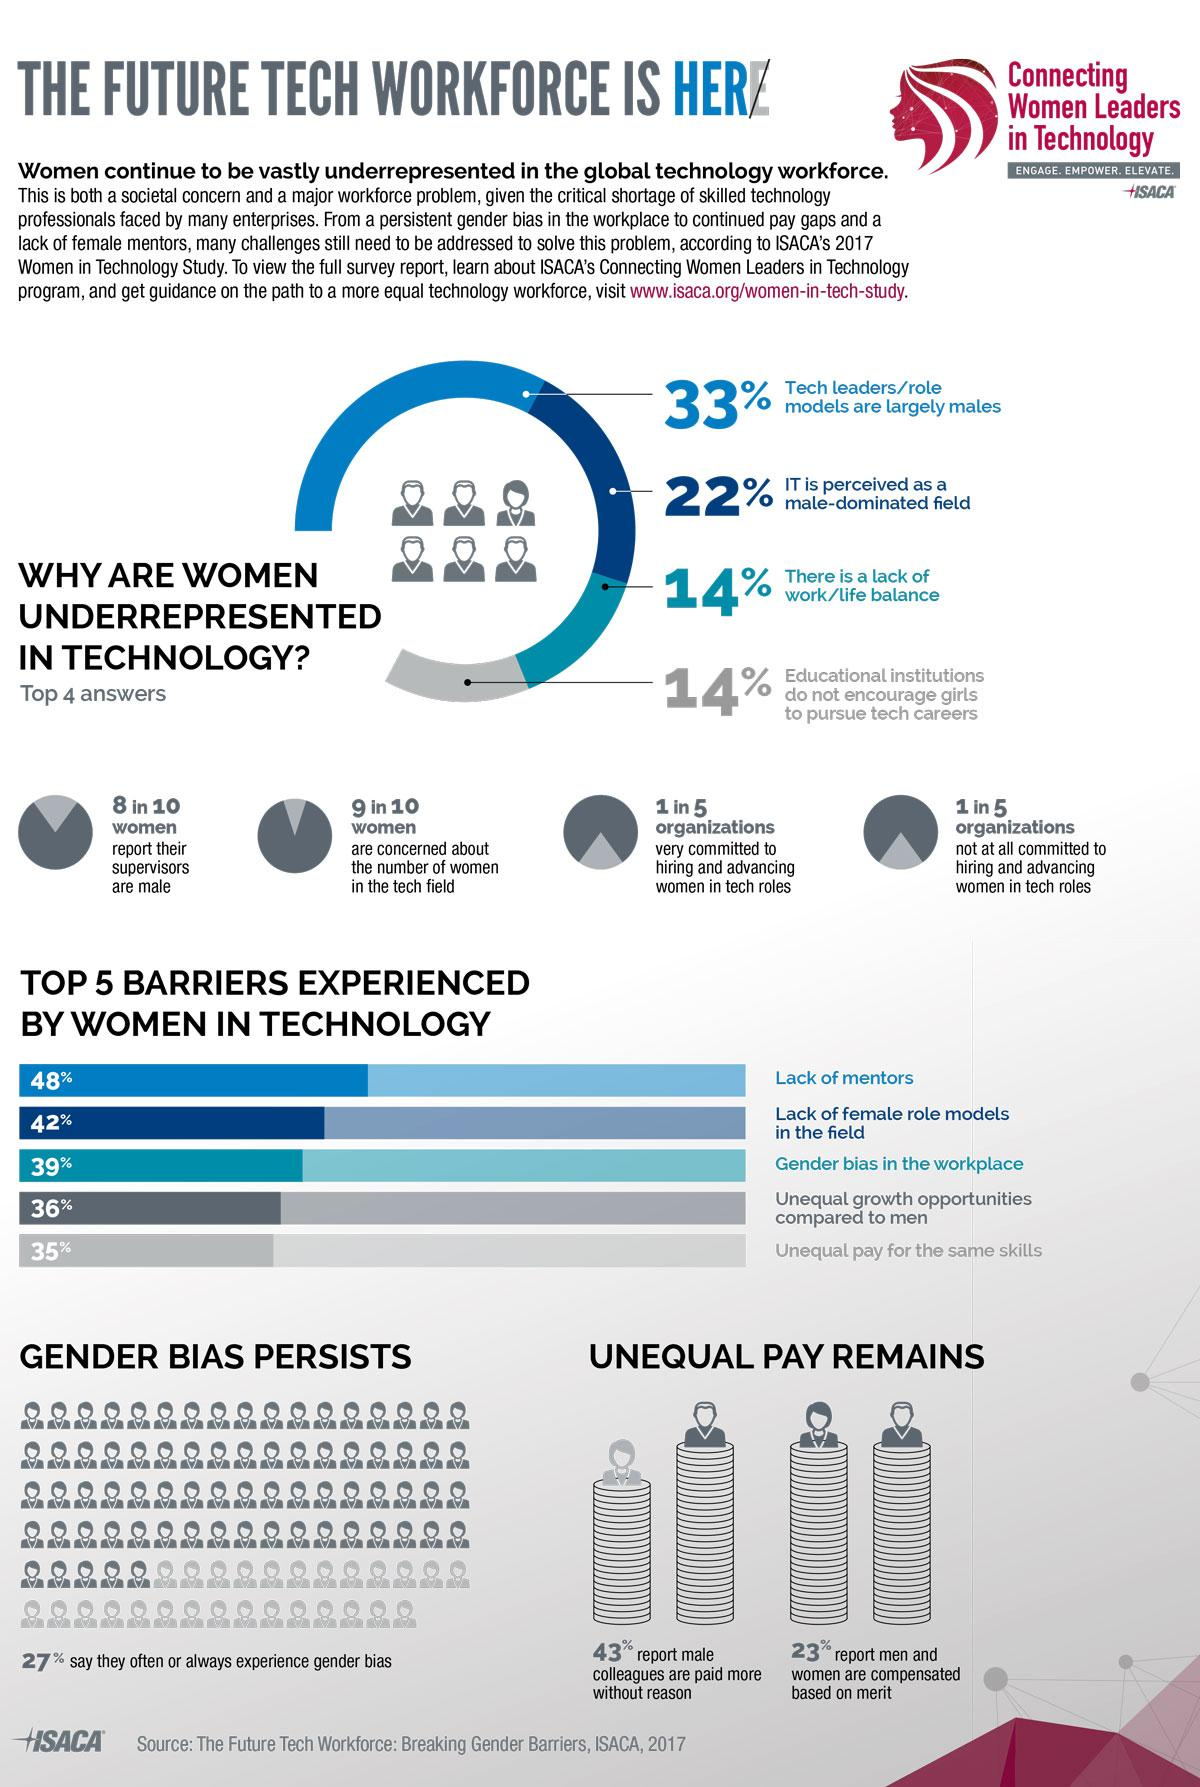Identify some key points in this picture. Eight out of ten females report that their supervisors are male. According to the survey, 43% of the women believe that men are paid more without any valid reason. According to a recent survey, 9 out of 10 women are concerned about the number of women in the tech field. 